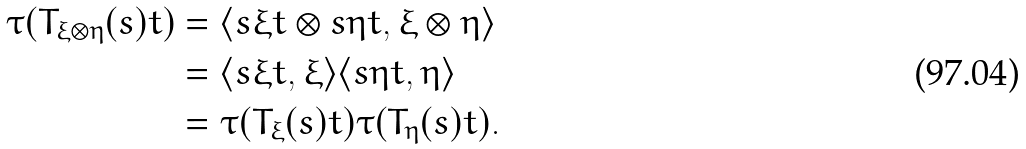Convert formula to latex. <formula><loc_0><loc_0><loc_500><loc_500>\tau ( T _ { \xi \otimes \eta } ( s ) t ) & = \langle s \xi t \otimes s \eta t , \xi \otimes \eta \rangle \\ & = \langle s \xi t , \xi \rangle \langle s \eta t , \eta \rangle \\ & = \tau ( T _ { \xi } ( s ) t ) \tau ( T _ { \eta } ( s ) t ) .</formula> 